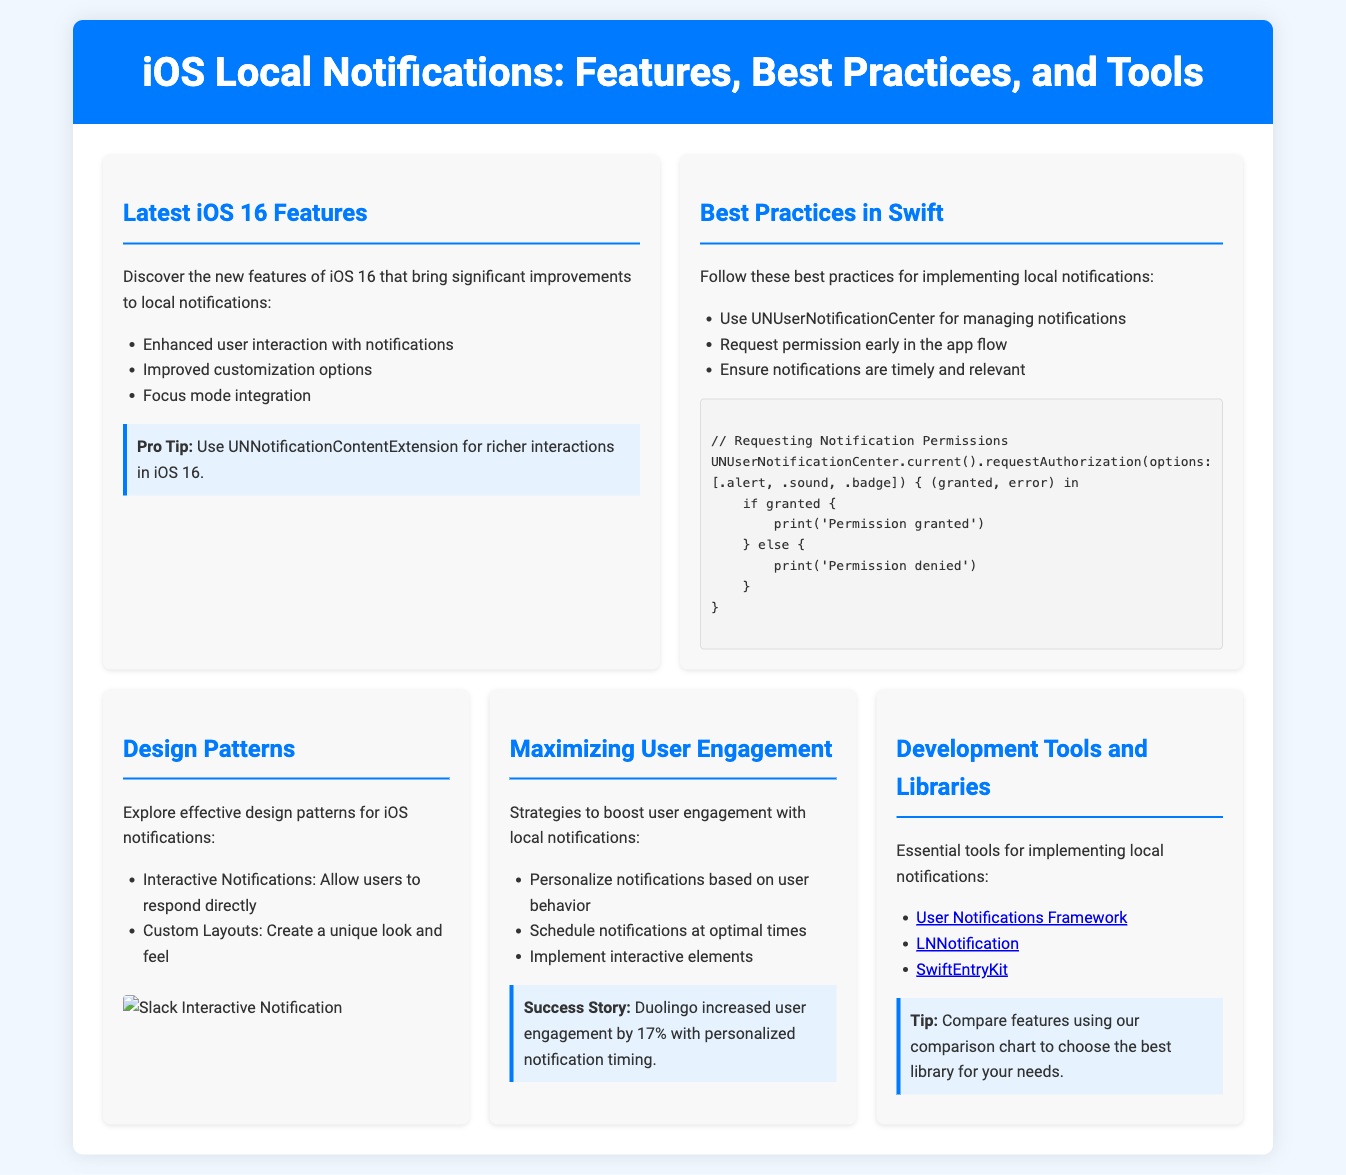What are the new features in iOS 16 for local notifications? The document lists enhancements such as increased user interaction, improved customization options, and focus mode integration for local notifications in iOS 16.
Answer: Enhanced user interaction, improved customization options, focus mode integration What is the main recommendation for requesting notification permissions? The document emphasizes the importance of requesting notification permissions early in the app flow as a best practice.
Answer: Request permission early in the app flow What is a key strategy to maximize user engagement with local notifications? The document suggests personalizing notifications based on user behavior as a critical approach to boost engagement.
Answer: Personalize notifications based on user behavior Which library is mentioned for local notifications in iOS apps? The document lists specific tools and libraries, including LNNotification, for implementing local notifications.
Answer: LNNotification What programming framework should be used for managing notifications in Swift? The document explicitly mentions using UNUserNotificationCenter to manage notifications.
Answer: UNUserNotificationCenter What success story highlights user engagement increase? The document mentions that Duolingo increased user engagement by 17% with personalized notification timing.
Answer: 17% What type of notifications allows users to respond directly? The document identifies interactive notifications as a design pattern that permits direct user responses.
Answer: Interactive Notifications What color is used for the header background? The header background color specified in the document is a shade of blue represented by the hex code #007aff.
Answer: #007aff 